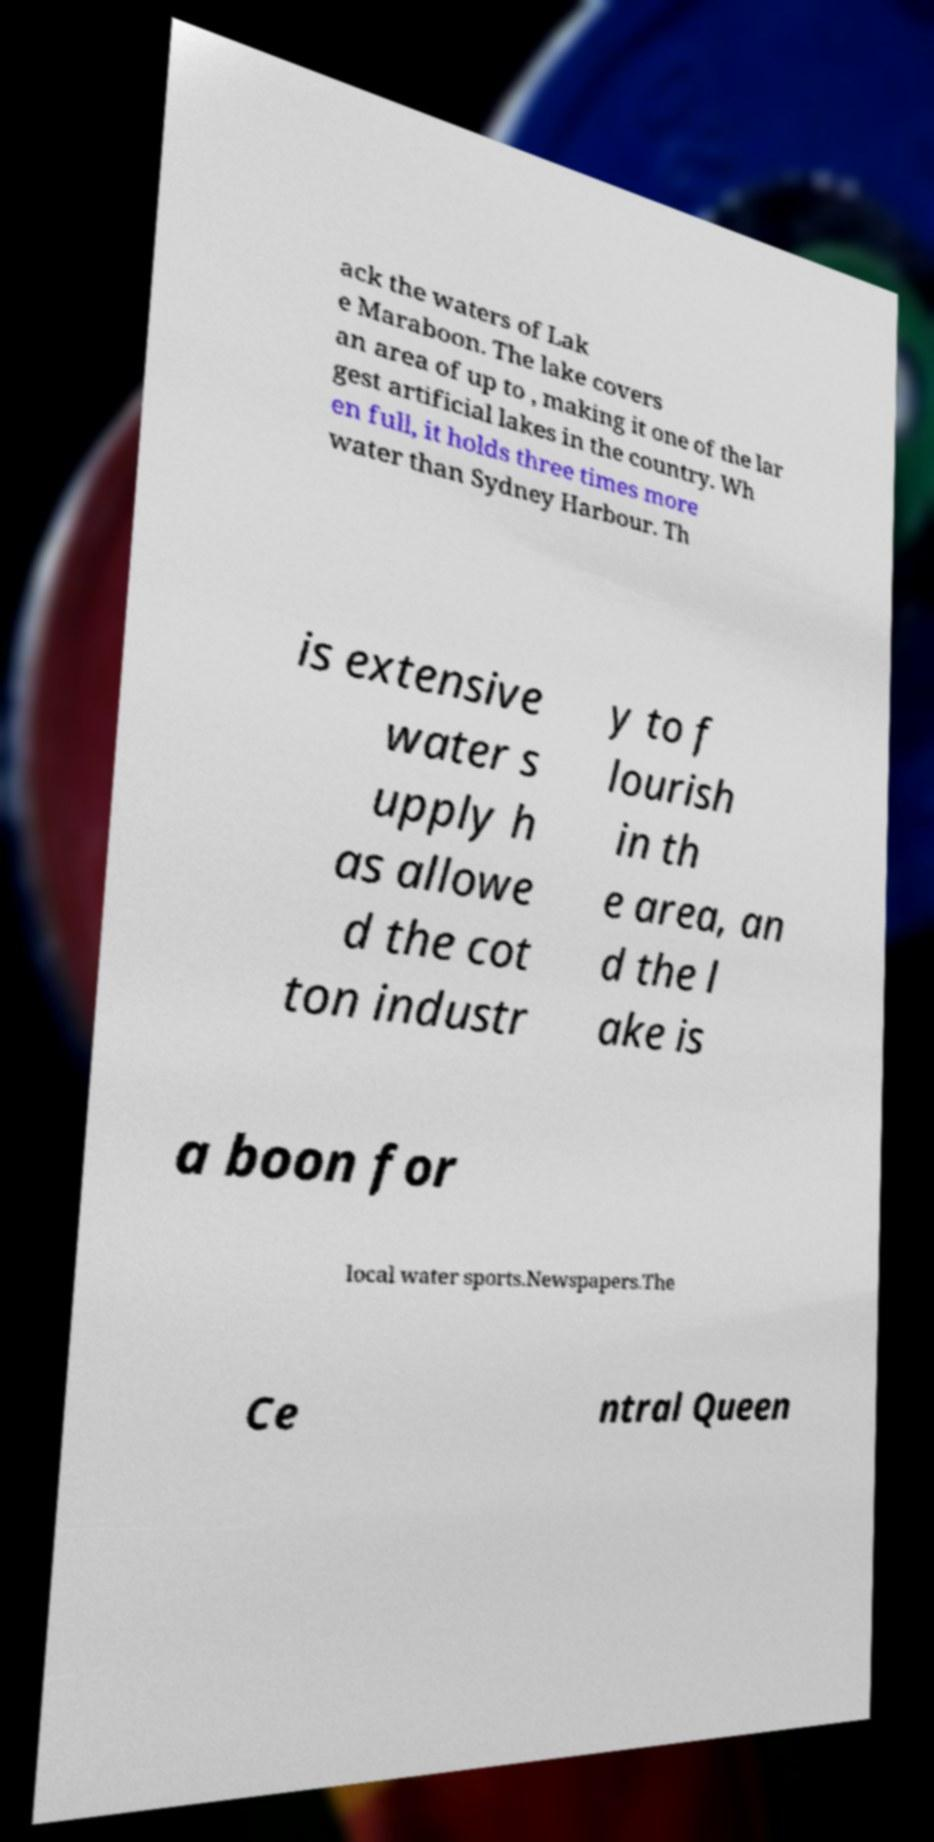Please read and relay the text visible in this image. What does it say? ack the waters of Lak e Maraboon. The lake covers an area of up to , making it one of the lar gest artificial lakes in the country. Wh en full, it holds three times more water than Sydney Harbour. Th is extensive water s upply h as allowe d the cot ton industr y to f lourish in th e area, an d the l ake is a boon for local water sports.Newspapers.The Ce ntral Queen 